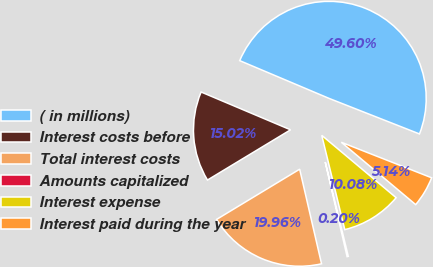Convert chart to OTSL. <chart><loc_0><loc_0><loc_500><loc_500><pie_chart><fcel>( in millions)<fcel>Interest costs before<fcel>Total interest costs<fcel>Amounts capitalized<fcel>Interest expense<fcel>Interest paid during the year<nl><fcel>49.6%<fcel>15.02%<fcel>19.96%<fcel>0.2%<fcel>10.08%<fcel>5.14%<nl></chart> 